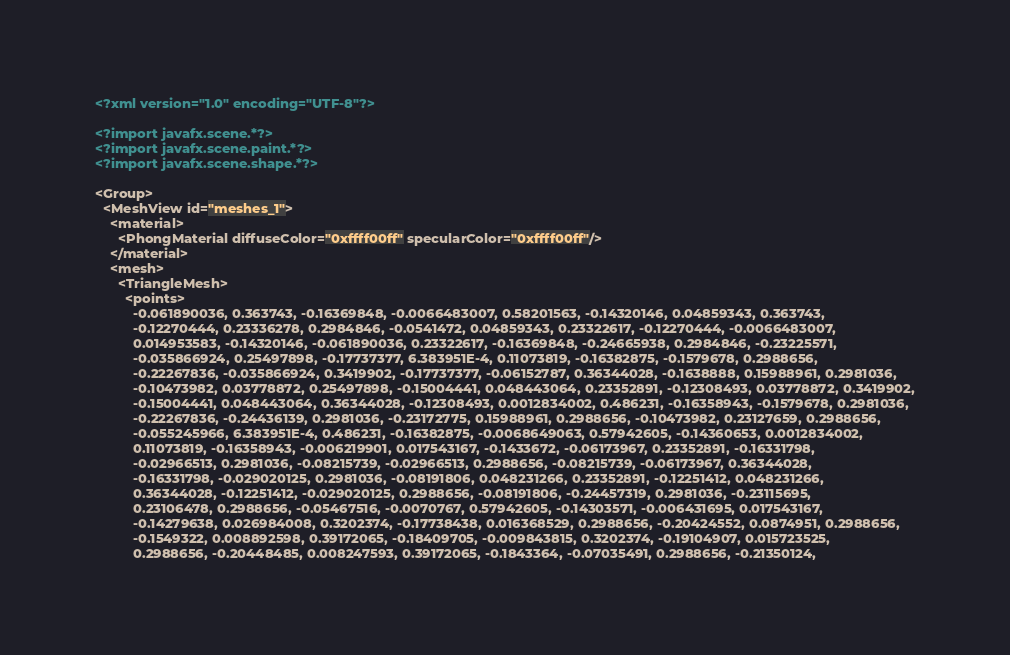<code> <loc_0><loc_0><loc_500><loc_500><_XML_><?xml version="1.0" encoding="UTF-8"?>

<?import javafx.scene.*?>
<?import javafx.scene.paint.*?>
<?import javafx.scene.shape.*?>

<Group>
  <MeshView id="meshes_1">
    <material>
      <PhongMaterial diffuseColor="0xffff00ff" specularColor="0xffff00ff"/>
    </material>
    <mesh>
      <TriangleMesh>
        <points>
          -0.061890036, 0.363743, -0.16369848, -0.0066483007, 0.58201563, -0.14320146, 0.04859343, 0.363743,
          -0.12270444, 0.23336278, 0.2984846, -0.0541472, 0.04859343, 0.23322617, -0.12270444, -0.0066483007,
          0.014953583, -0.14320146, -0.061890036, 0.23322617, -0.16369848, -0.24665938, 0.2984846, -0.23225571,
          -0.035866924, 0.25497898, -0.17737377, 6.383951E-4, 0.11073819, -0.16382875, -0.1579678, 0.2988656,
          -0.22267836, -0.035866924, 0.3419902, -0.17737377, -0.06152787, 0.36344028, -0.1638888, 0.15988961, 0.2981036,
          -0.10473982, 0.03778872, 0.25497898, -0.15004441, 0.048443064, 0.23352891, -0.12308493, 0.03778872, 0.3419902,
          -0.15004441, 0.048443064, 0.36344028, -0.12308493, 0.0012834002, 0.486231, -0.16358943, -0.1579678, 0.2981036,
          -0.22267836, -0.24436139, 0.2981036, -0.23172775, 0.15988961, 0.2988656, -0.10473982, 0.23127659, 0.2988656,
          -0.055245966, 6.383951E-4, 0.486231, -0.16382875, -0.0068649063, 0.57942605, -0.14360653, 0.0012834002,
          0.11073819, -0.16358943, -0.006219901, 0.017543167, -0.1433672, -0.06173967, 0.23352891, -0.16331798,
          -0.02966513, 0.2981036, -0.08215739, -0.02966513, 0.2988656, -0.08215739, -0.06173967, 0.36344028,
          -0.16331798, -0.029020125, 0.2981036, -0.08191806, 0.048231266, 0.23352891, -0.12251412, 0.048231266,
          0.36344028, -0.12251412, -0.029020125, 0.2988656, -0.08191806, -0.24457319, 0.2981036, -0.23115695,
          0.23106478, 0.2988656, -0.05467516, -0.0070767, 0.57942605, -0.14303571, -0.006431695, 0.017543167,
          -0.14279638, 0.026984008, 0.3202374, -0.17738438, 0.016368529, 0.2988656, -0.20424552, 0.0874951, 0.2988656,
          -0.1549322, 0.008892598, 0.39172065, -0.18409705, -0.009843815, 0.3202374, -0.19104907, 0.015723525,
          0.2988656, -0.20448485, 0.008247593, 0.39172065, -0.1843364, -0.07035491, 0.2988656, -0.21350124,</code> 